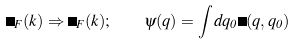Convert formula to latex. <formula><loc_0><loc_0><loc_500><loc_500>\Delta _ { F } ( k ) \Rightarrow \Delta _ { F } ( { k } ) ; \quad \psi ( { q } ) = \int d q _ { 0 } \Psi ( { q } , q _ { 0 } )</formula> 